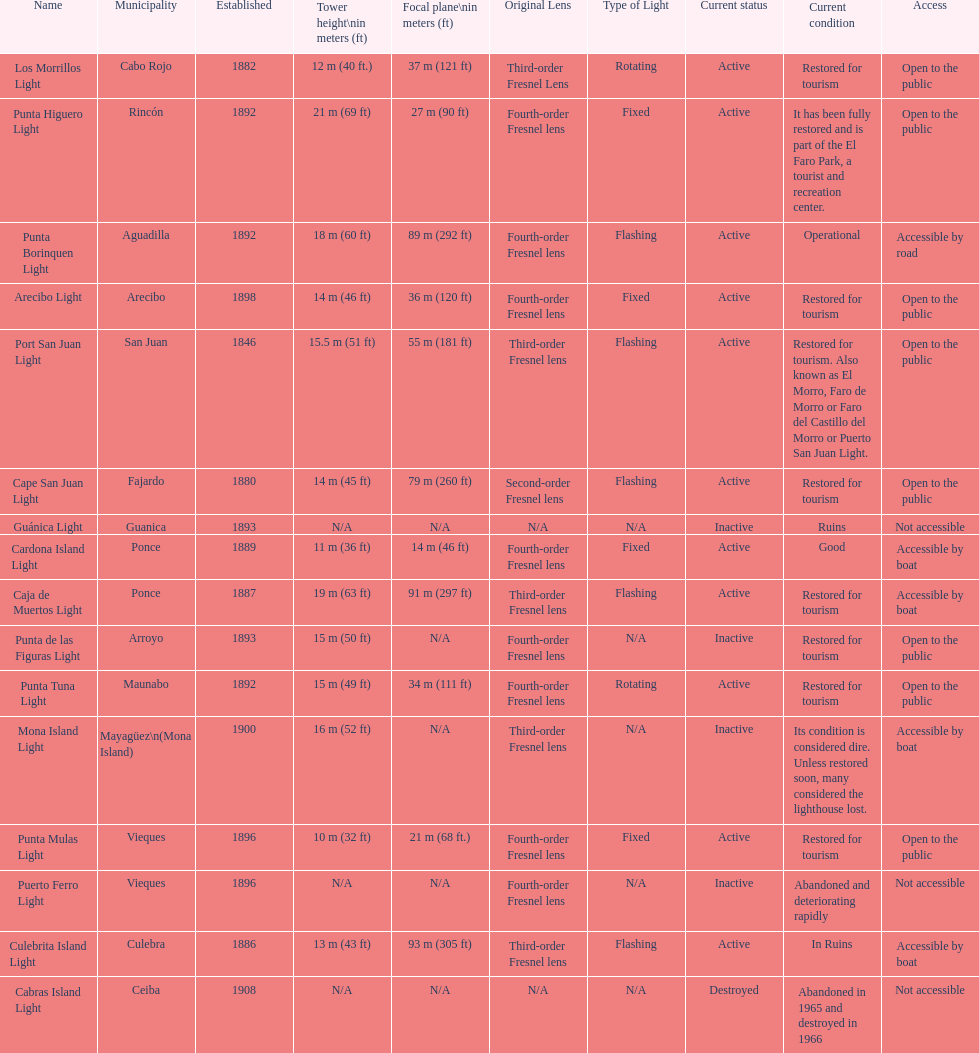Can you parse all the data within this table? {'header': ['Name', 'Municipality', 'Established', 'Tower height\\nin meters (ft)', 'Focal plane\\nin meters (ft)', 'Original Lens', 'Type of Light', 'Current status', 'Current condition', 'Access'], 'rows': [['Los Morrillos Light', 'Cabo Rojo', '1882', '12\xa0m (40\xa0ft.)', '37\xa0m (121\xa0ft)', 'Third-order Fresnel Lens', 'Rotating', 'Active', 'Restored for tourism', 'Open to the public'], ['Punta Higuero Light', 'Rincón', '1892', '21\xa0m (69\xa0ft)', '27\xa0m (90\xa0ft)', 'Fourth-order Fresnel lens', 'Fixed', 'Active', 'It has been fully restored and is part of the El Faro Park, a tourist and recreation center.', 'Open to the public'], ['Punta Borinquen Light', 'Aguadilla', '1892', '18\xa0m (60\xa0ft)', '89\xa0m (292\xa0ft)', 'Fourth-order Fresnel lens', 'Flashing', 'Active', 'Operational', 'Accessible by road'], ['Arecibo Light', 'Arecibo', '1898', '14\xa0m (46\xa0ft)', '36\xa0m (120\xa0ft)', 'Fourth-order Fresnel lens', 'Fixed', 'Active', 'Restored for tourism', 'Open to the public'], ['Port San Juan Light', 'San Juan', '1846', '15.5\xa0m (51\xa0ft)', '55\xa0m (181\xa0ft)', 'Third-order Fresnel lens', 'Flashing', 'Active', 'Restored for tourism. Also known as El Morro, Faro de Morro or Faro del Castillo del Morro or Puerto San Juan Light.', 'Open to the public'], ['Cape San Juan Light', 'Fajardo', '1880', '14\xa0m (45\xa0ft)', '79\xa0m (260\xa0ft)', 'Second-order Fresnel lens', 'Flashing', 'Active', 'Restored for tourism', 'Open to the public'], ['Guánica Light', 'Guanica', '1893', 'N/A', 'N/A', 'N/A', 'N/A', 'Inactive', 'Ruins', 'Not accessible'], ['Cardona Island Light', 'Ponce', '1889', '11\xa0m (36\xa0ft)', '14\xa0m (46\xa0ft)', 'Fourth-order Fresnel lens', 'Fixed', 'Active', 'Good', 'Accessible by boat'], ['Caja de Muertos Light', 'Ponce', '1887', '19\xa0m (63\xa0ft)', '91\xa0m (297\xa0ft)', 'Third-order Fresnel lens', 'Flashing', 'Active', 'Restored for tourism', 'Accessible by boat'], ['Punta de las Figuras Light', 'Arroyo', '1893', '15\xa0m (50\xa0ft)', 'N/A', 'Fourth-order Fresnel lens', 'N/A', 'Inactive', 'Restored for tourism', 'Open to the public'], ['Punta Tuna Light', 'Maunabo', '1892', '15\xa0m (49\xa0ft)', '34\xa0m (111\xa0ft)', 'Fourth-order Fresnel lens', 'Rotating', 'Active', 'Restored for tourism', 'Open to the public'], ['Mona Island Light', 'Mayagüez\\n(Mona Island)', '1900', '16\xa0m (52\xa0ft)', 'N/A', 'Third-order Fresnel lens', 'N/A', 'Inactive', 'Its condition is considered dire. Unless restored soon, many considered the lighthouse lost.', 'Accessible by boat'], ['Punta Mulas Light', 'Vieques', '1896', '10\xa0m (32\xa0ft)', '21\xa0m (68\xa0ft.)', 'Fourth-order Fresnel lens', 'Fixed', 'Active', 'Restored for tourism', 'Open to the public'], ['Puerto Ferro Light', 'Vieques', '1896', 'N/A', 'N/A', 'Fourth-order Fresnel lens', 'N/A', 'Inactive', 'Abandoned and deteriorating rapidly', 'Not accessible'], ['Culebrita Island Light', 'Culebra', '1886', '13\xa0m (43\xa0ft)', '93\xa0m (305\xa0ft)', 'Third-order Fresnel lens', 'Flashing', 'Active', 'In Ruins', 'Accessible by boat'], ['Cabras Island Light', 'Ceiba', '1908', 'N/A', 'N/A', 'N/A', 'N/A', 'Destroyed', 'Abandoned in 1965 and destroyed in 1966', 'Not accessible']]} Number of lighthouses that begin with the letter p 7. 